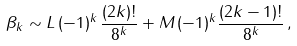<formula> <loc_0><loc_0><loc_500><loc_500>\beta _ { k } \sim L \, ( - 1 ) ^ { k } \, \frac { ( 2 k ) ! } { 8 ^ { k } } + M \, ( - 1 ) ^ { k } \frac { ( 2 k - 1 ) ! } { 8 ^ { k } } \, ,</formula> 